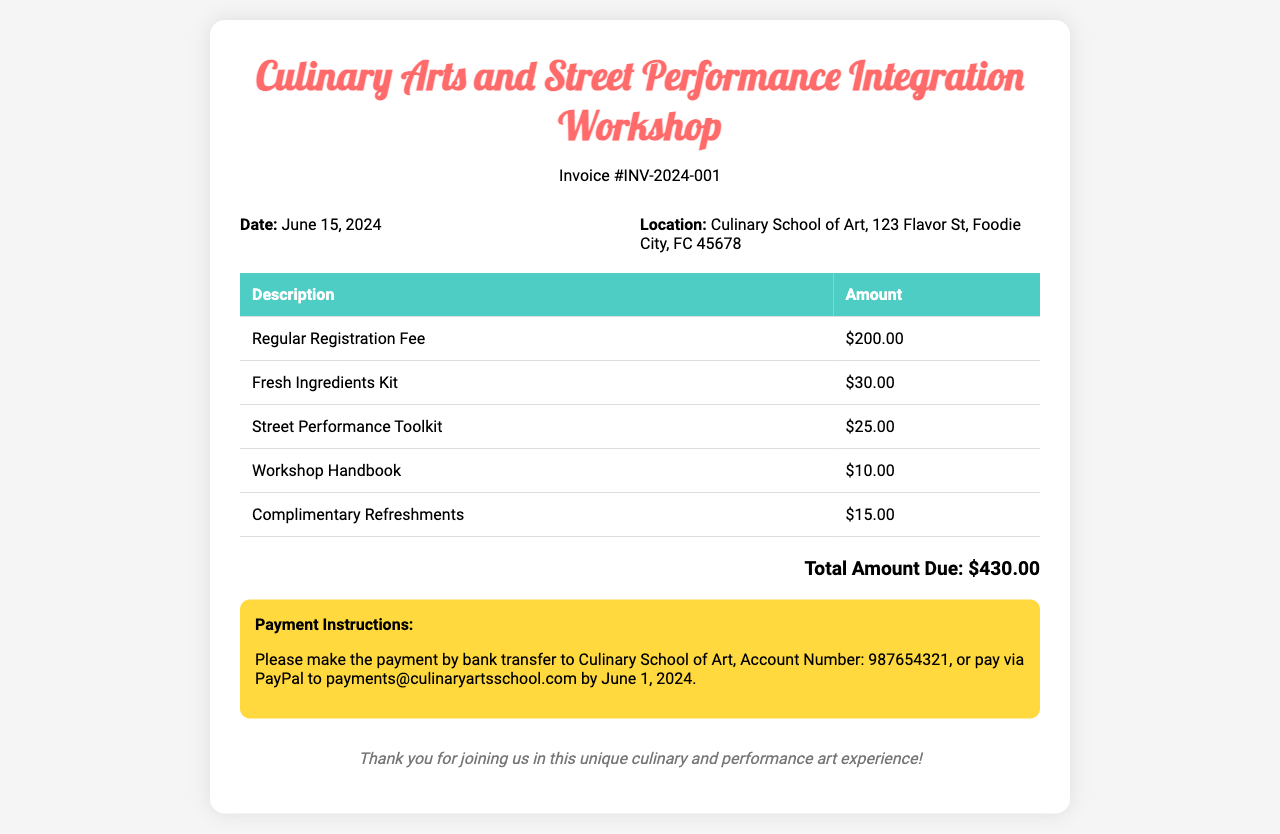What is the invoice number? The invoice number is listed under the header and serves as a unique identifier for the document.
Answer: INV-2024-001 What is the date of the workshop? The date of the workshop is specified in the document, providing participants with essential scheduling information.
Answer: June 15, 2024 What is the total amount due? The total amount due summarizes the costs listed for the workshop and is found at the bottom of the invoice.
Answer: $430.00 How much is the Regular Registration Fee? The Regular Registration Fee is explicitly listed in the table of fees, indicating the cost for participants to register.
Answer: $200.00 What types of materials are included in the workshop fee? The types of materials included are described in the fee table, which lists various kits and handbooks.
Answer: Fresh Ingredients Kit, Street Performance Toolkit, Workshop Handbook, Complimentary Refreshments What payment methods are mentioned? The document outlines the accepted payment methods, including bank transfer and PayPal, which are important for the participant's convenience.
Answer: Bank transfer, PayPal Where is the workshop located? The location is provided in the information section, crucial for attendees to find the venue.
Answer: Culinary School of Art, 123 Flavor St, Foodie City, FC 45678 By when should the payment be made? The deadline for payment is mentioned, which is significant for participants to ensure their spot in the workshop.
Answer: June 1, 2024 What is included in the Street Performance Toolkit? The mention of the Street Performance Toolkit in the document indicates it is a part of the materials provided for the workshop, but specifics aren't detailed.
Answer: Not specified 